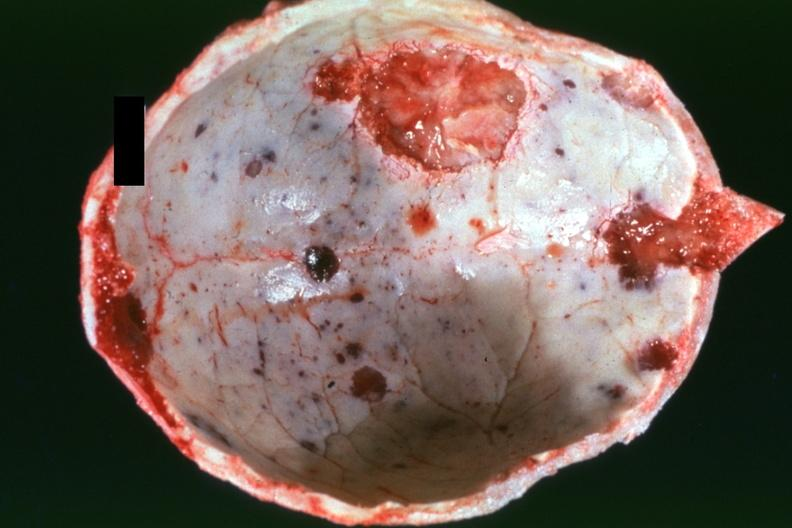what is present?
Answer the question using a single word or phrase. Bone, calvarium 